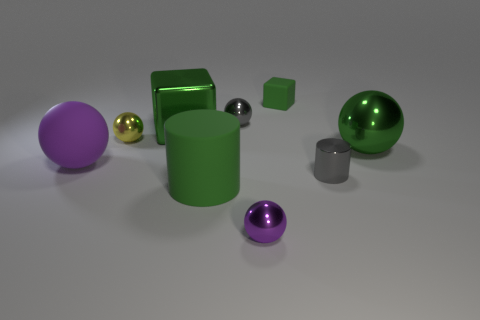How could we depict a sense of scale in this image? To depict a sense of scale, one could add a recognizable object such as a pencil or coin next to the objects. This comparison would give viewers a reference point to gauge the size of the various shapes presented in the image. 